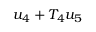<formula> <loc_0><loc_0><loc_500><loc_500>u _ { 4 } + T _ { 4 } u _ { 5 }</formula> 